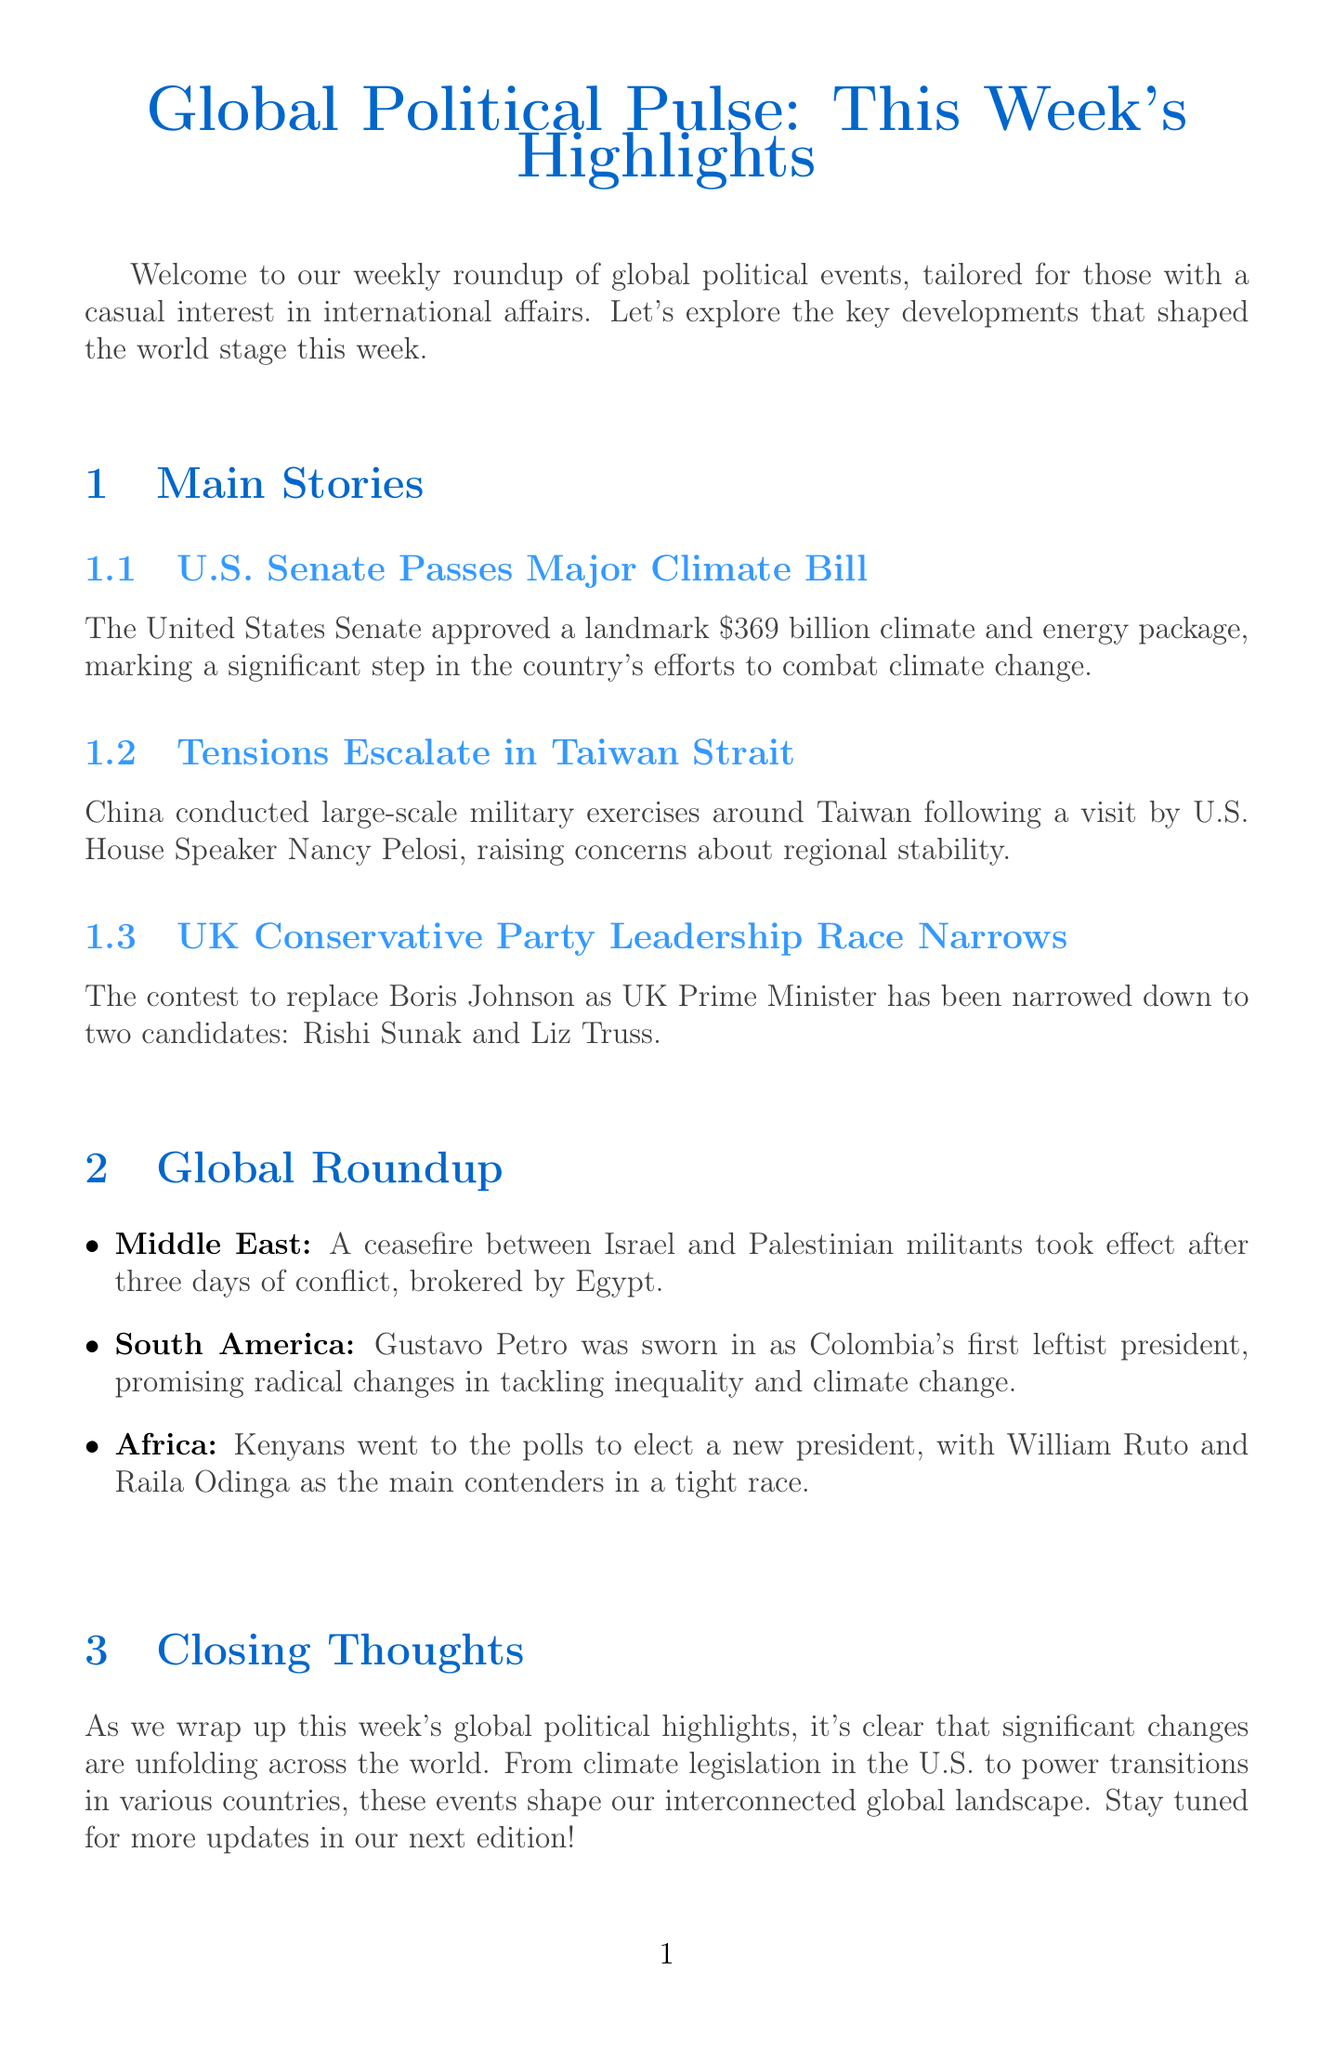What is the title of the newsletter? The title of the newsletter is mentioned at the beginning of the document.
Answer: Global Political Pulse: This Week's Highlights How much is the climate and energy package approved by the U.S. Senate? The document provides the specific amount of the climate and energy package in the summary of the main stories section.
Answer: $369 billion Who are the two candidates in the UK Conservative Party leadership race? The candidates are listed in the summary of the main stories regarding the leadership race.
Answer: Rishi Sunak and Liz Truss What region experienced a ceasefire between Israel and Palestinian militants? The region is mentioned in the global roundup of events in the document.
Answer: Middle East What was Gustavo Petro's position when he was inaugurated? The summary in the global roundup provides information about Gustavo Petro’s inauguration.
Answer: President What is the title of the infographic related to the Climate Bill? The infographic title is stated explicitly in the main stories section concerning the climate bill.
Answer: Key Allocations in the Climate Bill Which country conducted military exercises around Taiwan? The country is identified in the summary of the main stories related to the Taiwan Strait tensions.
Answer: China What do the contrasting policy positions of Sunak and Truss address? The document lists categories that highlight the differences between the two candidates' positions.
Answer: Tax Cuts, Brexit Stance, China Policy, Climate Action What event took place in Kenya recently? The document summarizes the event happening in Kenya in the global roundup section.
Answer: Presidential Election 